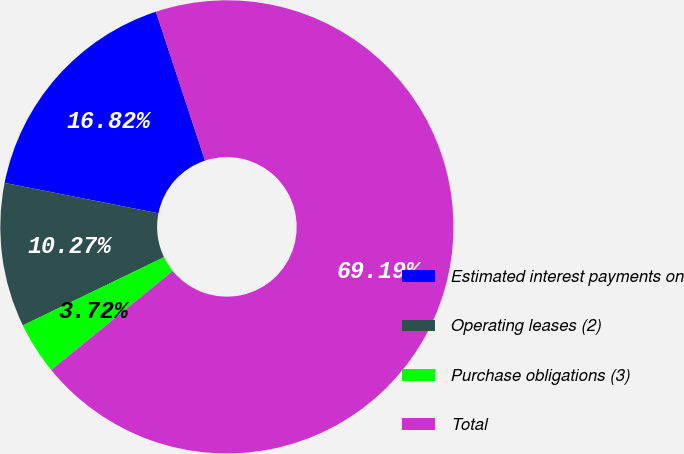Convert chart. <chart><loc_0><loc_0><loc_500><loc_500><pie_chart><fcel>Estimated interest payments on<fcel>Operating leases (2)<fcel>Purchase obligations (3)<fcel>Total<nl><fcel>16.82%<fcel>10.27%<fcel>3.72%<fcel>69.19%<nl></chart> 